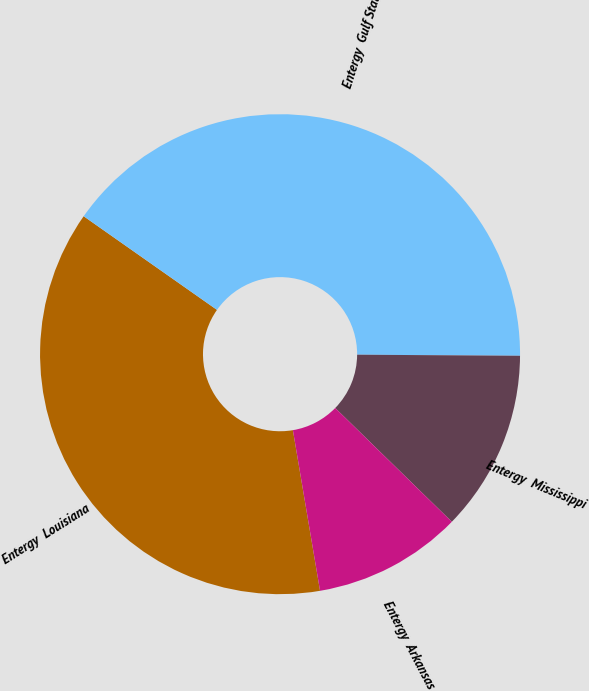Convert chart to OTSL. <chart><loc_0><loc_0><loc_500><loc_500><pie_chart><fcel>Entergy  Louisiana<fcel>Entergy  Gulf States<fcel>Entergy  Mississippi<fcel>Entergy  Arkansas<nl><fcel>37.41%<fcel>40.36%<fcel>12.2%<fcel>10.03%<nl></chart> 